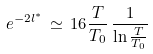Convert formula to latex. <formula><loc_0><loc_0><loc_500><loc_500>e ^ { - 2 l ^ { * } } \, \simeq \, 1 6 \frac { T } { T _ { 0 } } \, \frac { 1 } { \ln \frac { T } { T _ { 0 } } }</formula> 